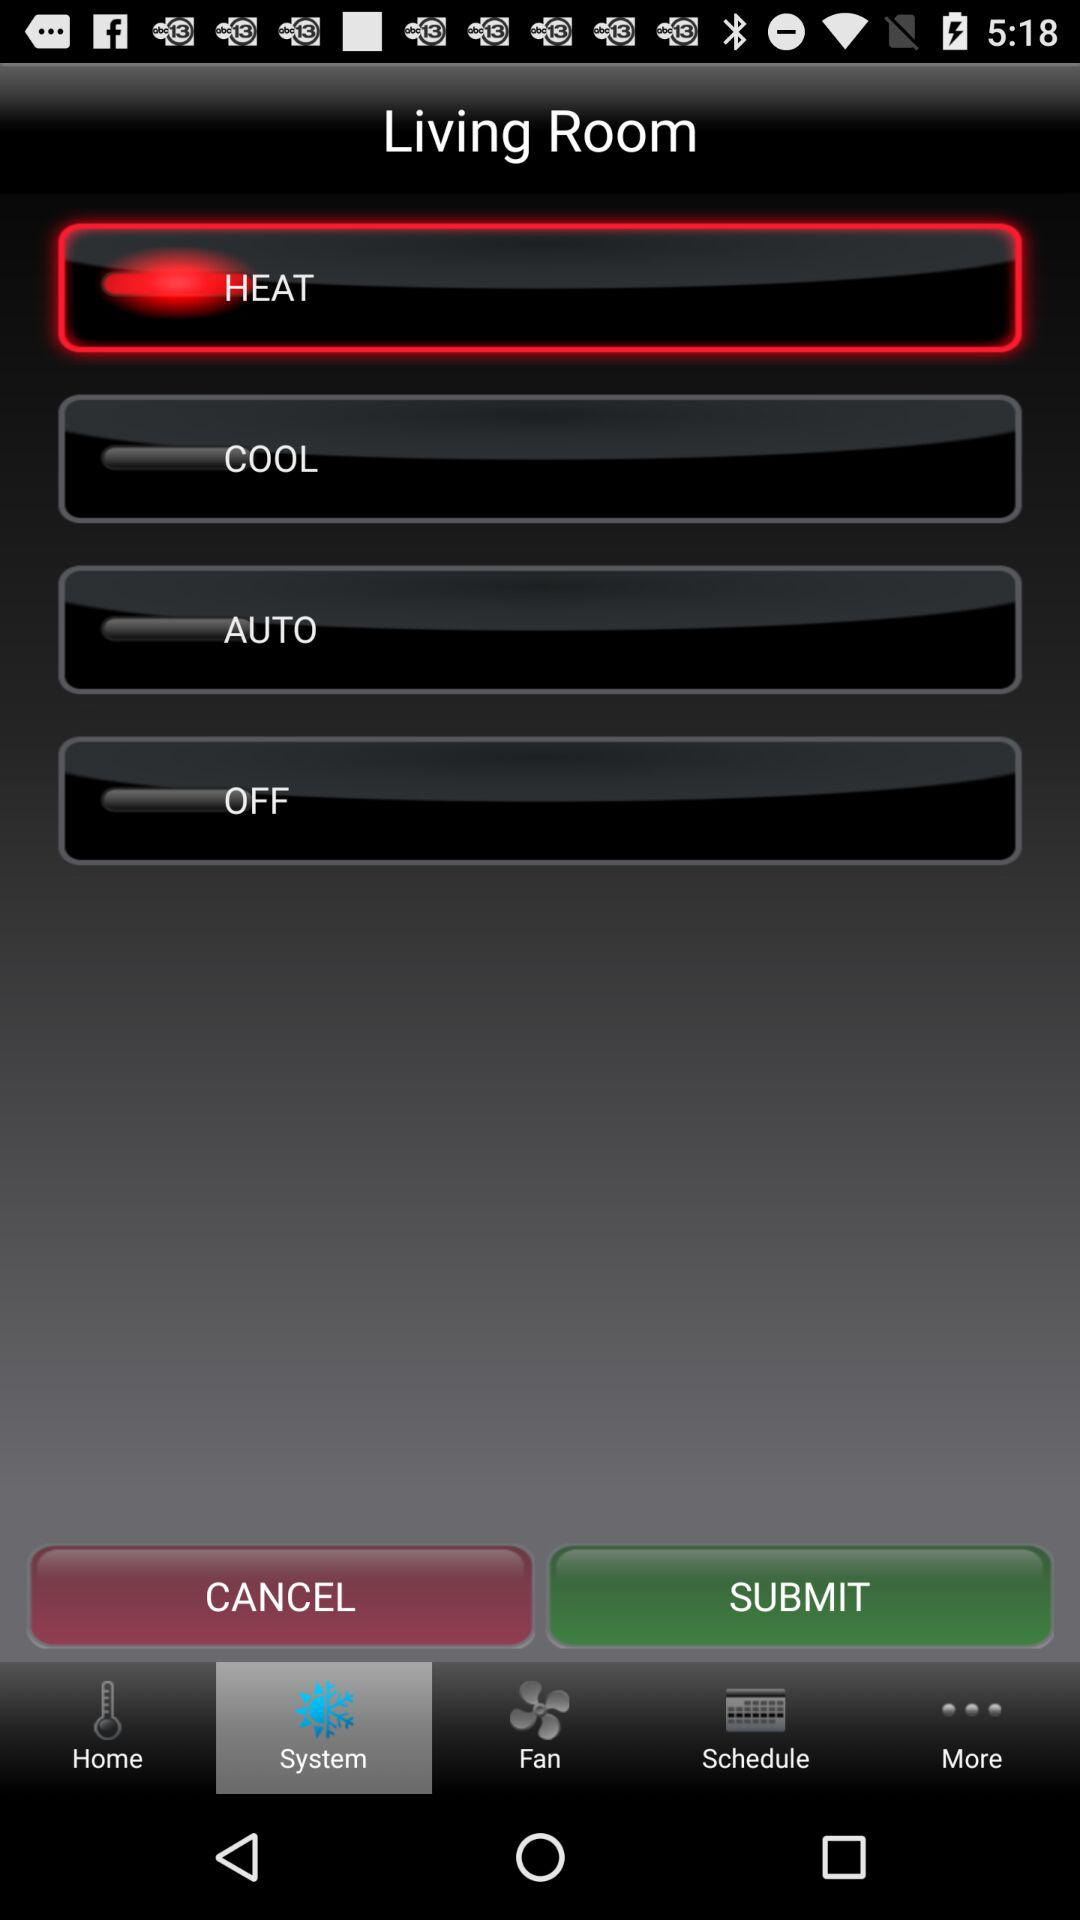Which option is selected? The selected option is heat. 